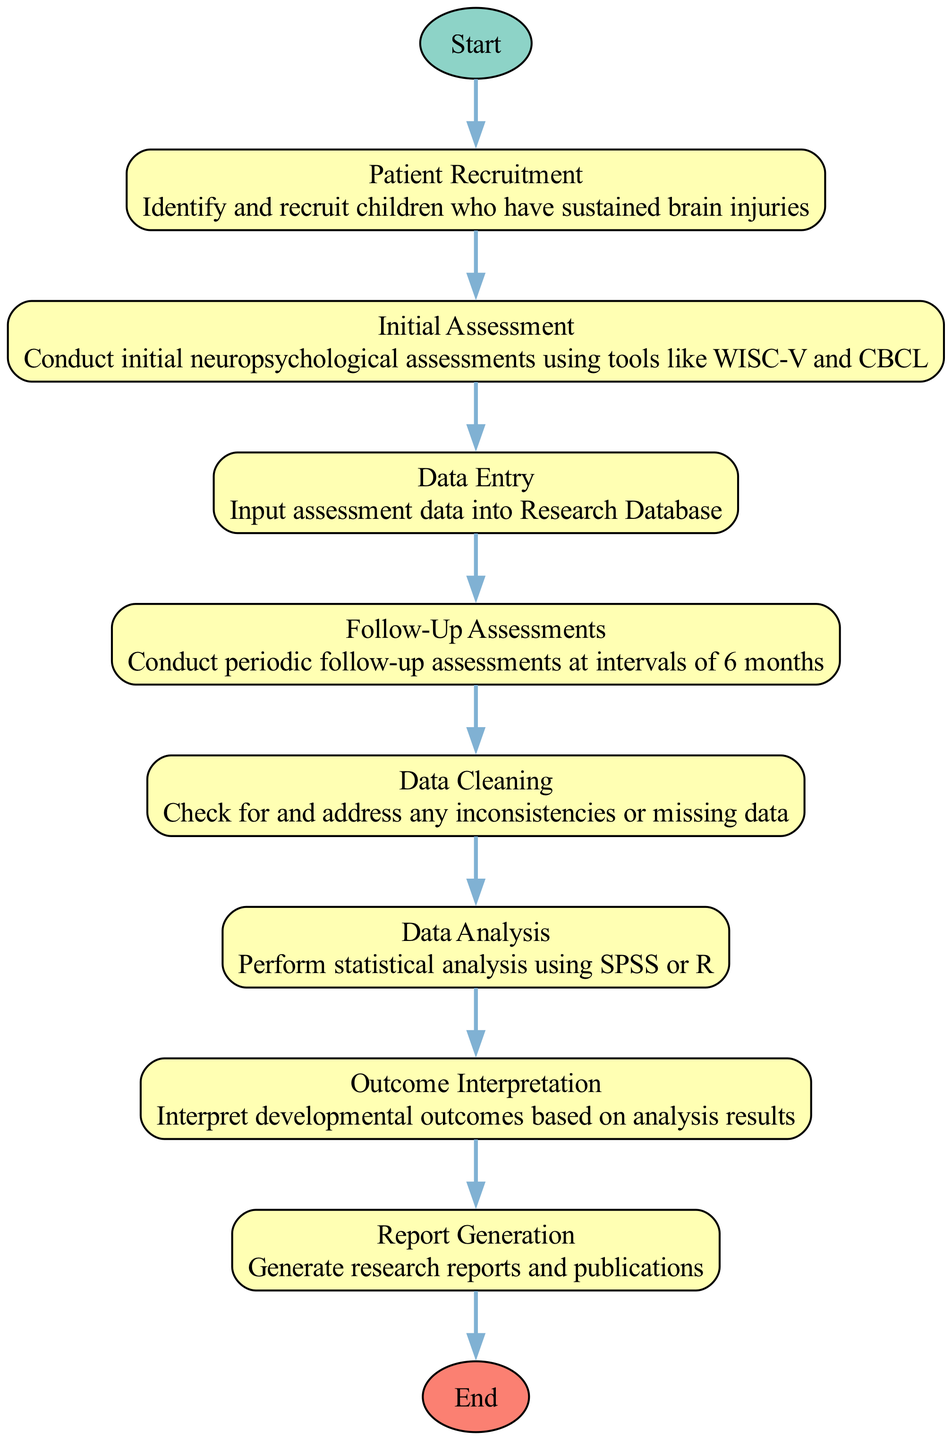What is the first step in the workflow? According to the diagram, the first step is represented by the "Start" node, which transitions to "Patient Recruitment." Therefore, the first action in this workflow chain is "Patient Recruitment."
Answer: Patient Recruitment How many processes are there in total? The diagram consists of several nodes described as processes: "Patient Recruitment," "Initial Assessment," "Data Entry," "Follow-Up Assessments," "Data Cleaning," "Data Analysis," "Outcome Interpretation," and "Report Generation." Counting these, there are 8 processes in total.
Answer: 8 What follows the "Data Cleaning" step? After "Data Cleaning," the flow proceeds to the "Data Analysis" step, as indicated by the connection from "Data Cleaning" to "Data Analysis." This means that "Data Analysis" is the next process to be conducted.
Answer: Data Analysis What is the last step before the end of the workflow? The last process indicated before reaching the "End" node is "Report Generation." The flowchart outlines that after interpreting the outcomes, the next action is generating reports, which leads to the end of the process.
Answer: Report Generation What tools are mentioned for the initial assessment? The diagram states that the initial assessment involves tools such as WISC-V and CBCL. These tools are explicitly described as part of the "Initial Assessment" step, indicating their importance in the workflow.
Answer: WISC-V and CBCL How frequently are follow-up assessments conducted? The flowchart specifies that follow-up assessments occur at intervals of 6 months. This detail is part of the description for the "Follow-Up Assessments" process in the diagram.
Answer: 6 months Which step comes after the "Outcome Interpretation"? The next step after "Outcome Interpretation" is "Report Generation," as the diagram shows a direct connection leading to this process. Thus, one must proceed to "Report Generation" to continue the workflow.
Answer: Report Generation Which processes are directly connected to the "Data Analysis" process? The "Data Cleaning" process directly feeds into "Data Analysis," as per the diagram. Therefore, the connection from "Data Cleaning" to "Data Analysis" highlights which process leads into the analysis stage.
Answer: Data Cleaning 